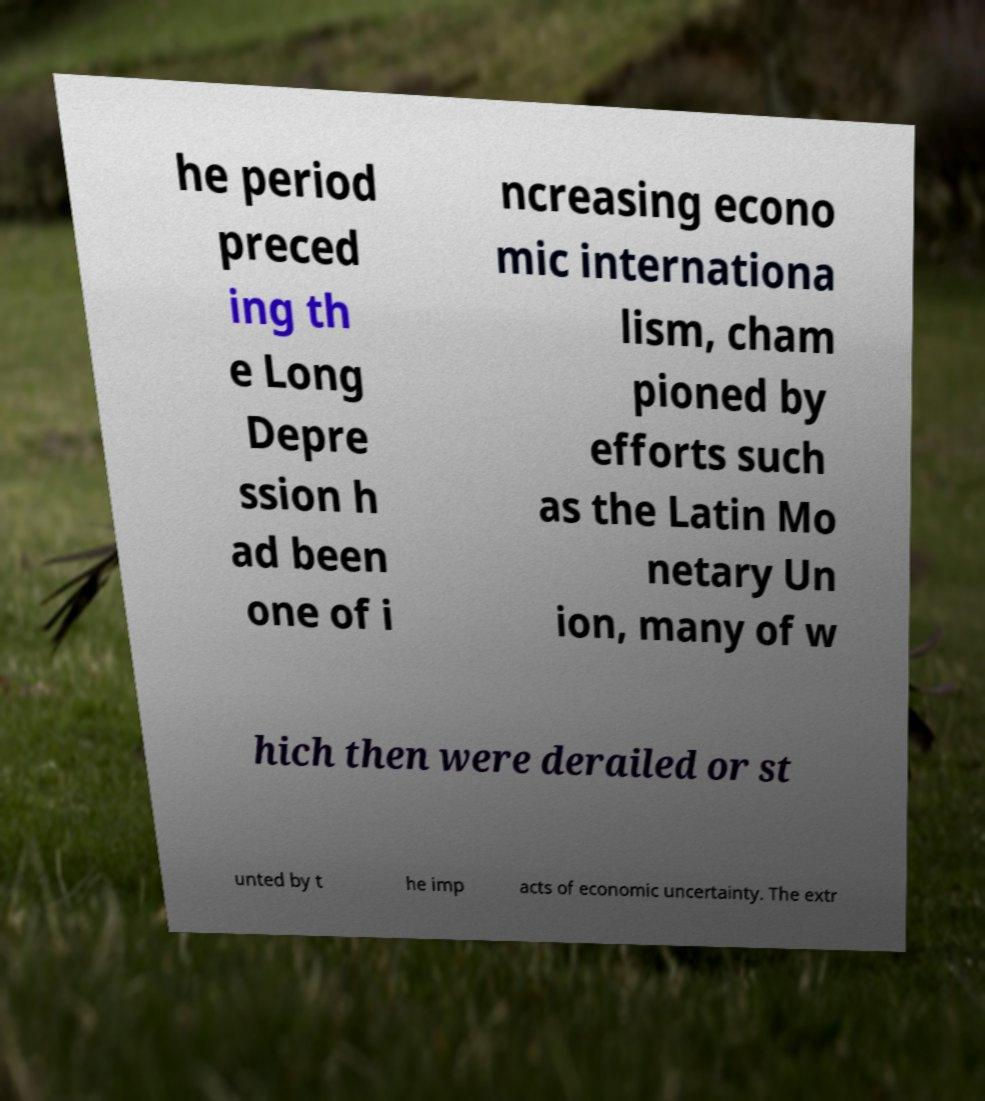What messages or text are displayed in this image? I need them in a readable, typed format. he period preced ing th e Long Depre ssion h ad been one of i ncreasing econo mic internationa lism, cham pioned by efforts such as the Latin Mo netary Un ion, many of w hich then were derailed or st unted by t he imp acts of economic uncertainty. The extr 